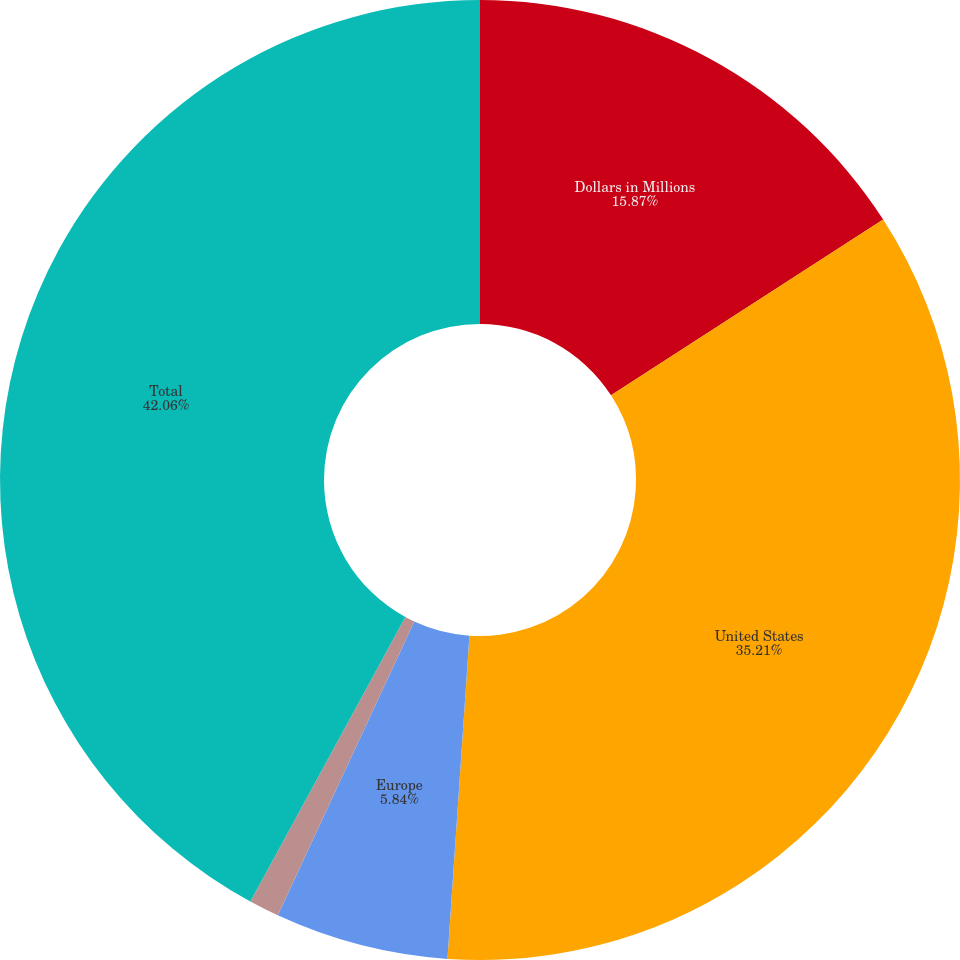Convert chart to OTSL. <chart><loc_0><loc_0><loc_500><loc_500><pie_chart><fcel>Dollars in Millions<fcel>United States<fcel>Europe<fcel>Rest of the World<fcel>Total<nl><fcel>15.87%<fcel>35.21%<fcel>5.84%<fcel>1.02%<fcel>42.06%<nl></chart> 